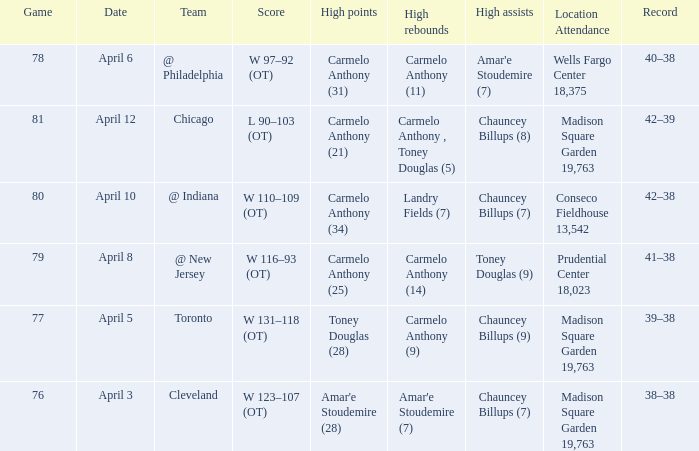Name the location attendance april 5 Madison Square Garden 19,763. 